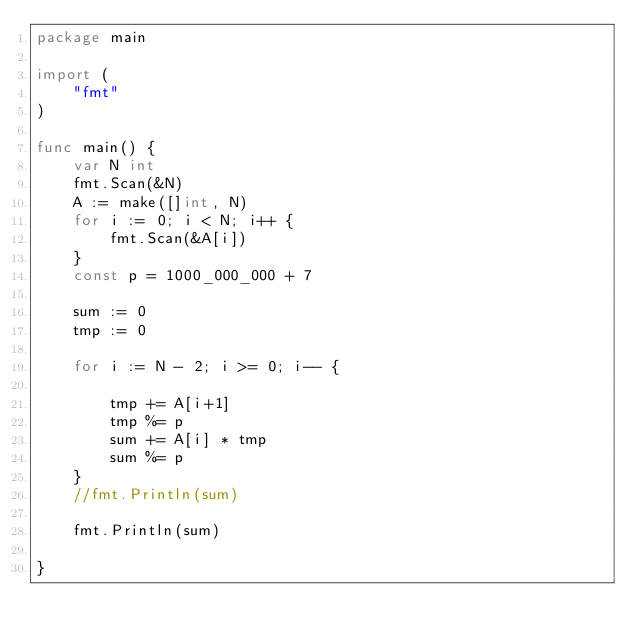<code> <loc_0><loc_0><loc_500><loc_500><_Go_>package main

import (
	"fmt"
)

func main() {
	var N int
	fmt.Scan(&N)
	A := make([]int, N)
	for i := 0; i < N; i++ {
		fmt.Scan(&A[i])
	}
	const p = 1000_000_000 + 7

	sum := 0
	tmp := 0

	for i := N - 2; i >= 0; i-- {

		tmp += A[i+1]
		tmp %= p
		sum += A[i] * tmp
		sum %= p
	}
	//fmt.Println(sum)

	fmt.Println(sum)

}
</code> 